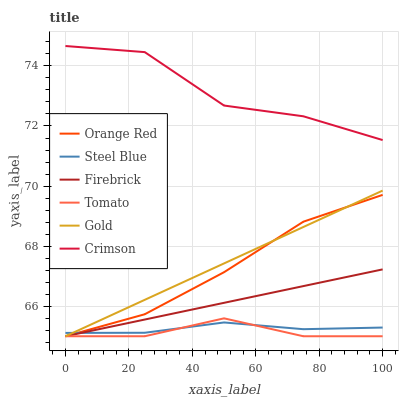Does Tomato have the minimum area under the curve?
Answer yes or no. Yes. Does Crimson have the maximum area under the curve?
Answer yes or no. Yes. Does Gold have the minimum area under the curve?
Answer yes or no. No. Does Gold have the maximum area under the curve?
Answer yes or no. No. Is Gold the smoothest?
Answer yes or no. Yes. Is Crimson the roughest?
Answer yes or no. Yes. Is Firebrick the smoothest?
Answer yes or no. No. Is Firebrick the roughest?
Answer yes or no. No. Does Steel Blue have the lowest value?
Answer yes or no. No. Does Gold have the highest value?
Answer yes or no. No. Is Steel Blue less than Crimson?
Answer yes or no. Yes. Is Crimson greater than Tomato?
Answer yes or no. Yes. Does Steel Blue intersect Crimson?
Answer yes or no. No. 